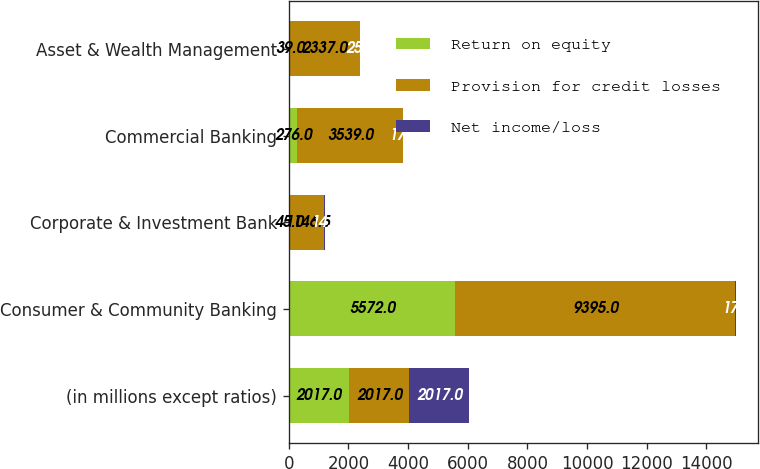<chart> <loc_0><loc_0><loc_500><loc_500><stacked_bar_chart><ecel><fcel>(in millions except ratios)<fcel>Consumer & Community Banking<fcel>Corporate & Investment Bank<fcel>Commercial Banking<fcel>Asset & Wealth Management<nl><fcel>Return on equity<fcel>2017<fcel>5572<fcel>45<fcel>276<fcel>39<nl><fcel>Provision for credit losses<fcel>2017<fcel>9395<fcel>1146.5<fcel>3539<fcel>2337<nl><fcel>Net income/loss<fcel>2017<fcel>17<fcel>14<fcel>17<fcel>25<nl></chart> 